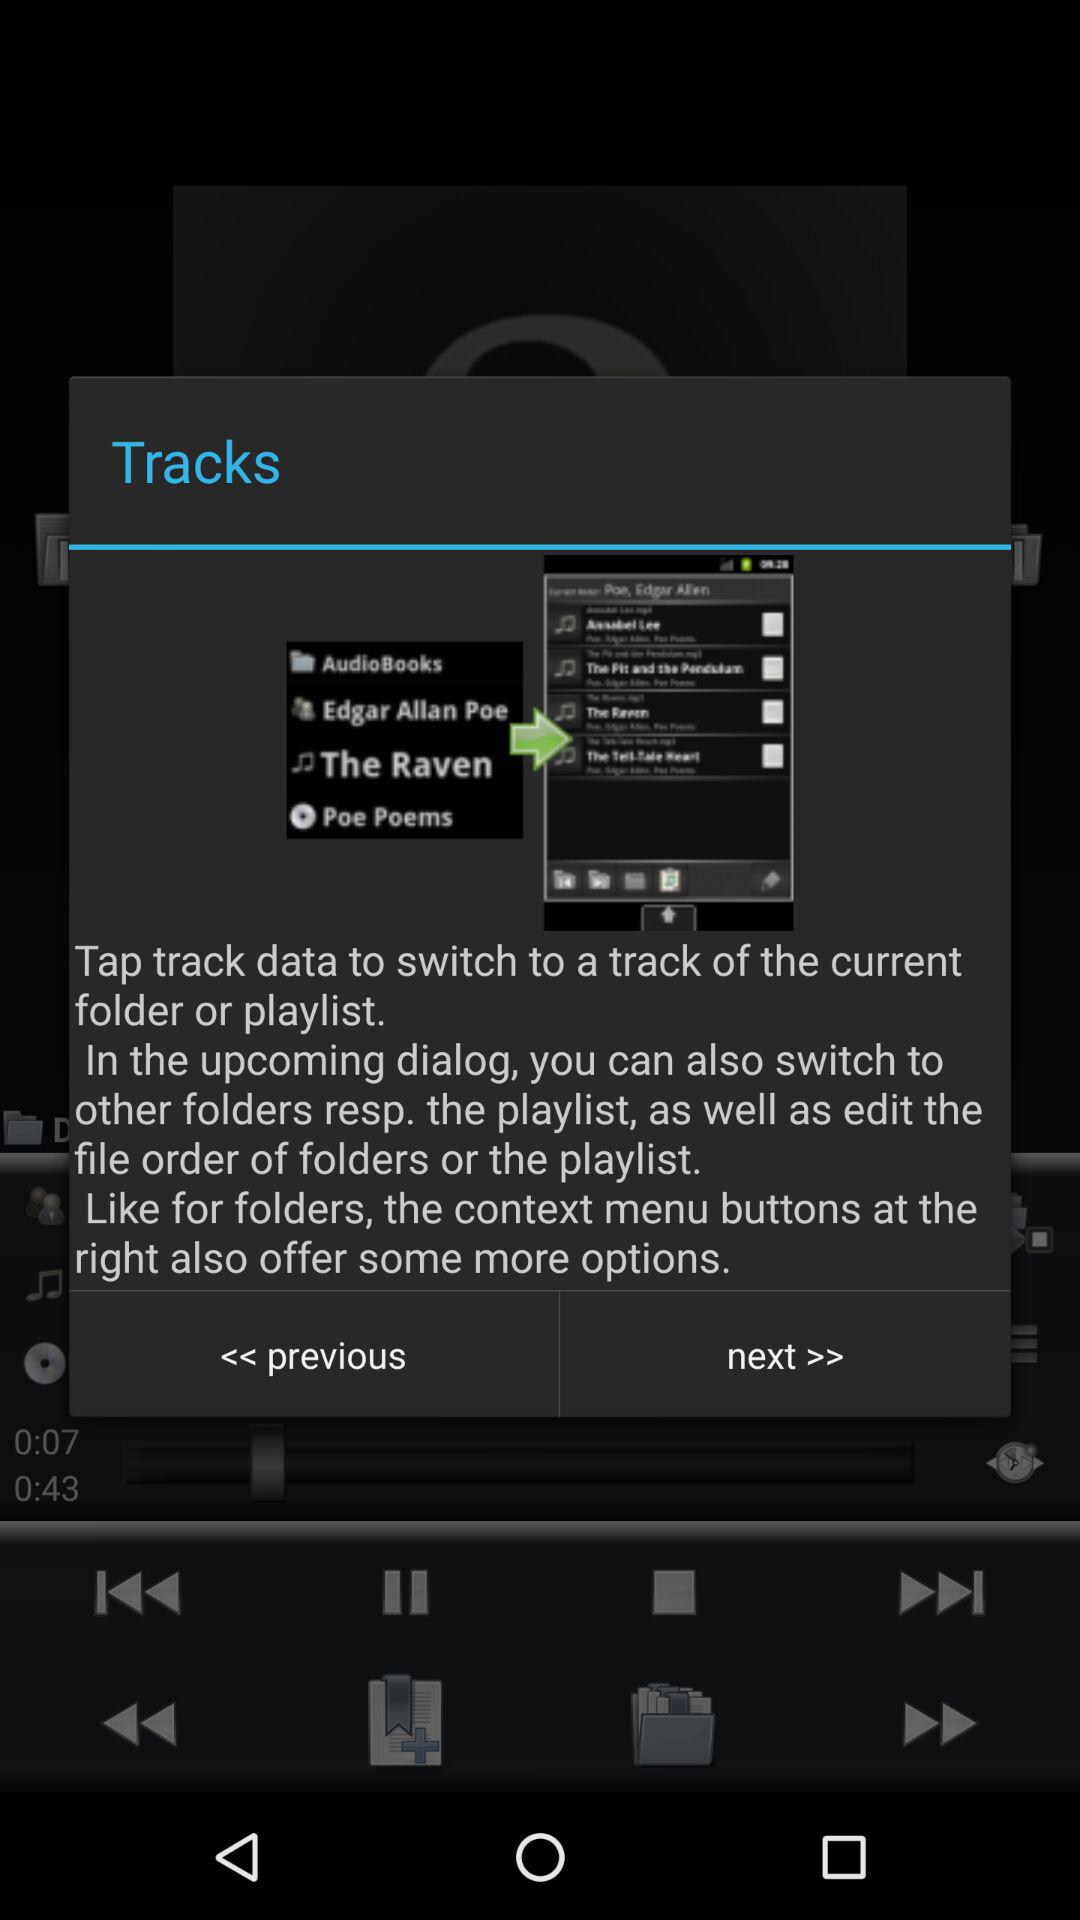How to use tracks?
When the provided information is insufficient, respond with <no answer>. <no answer> 